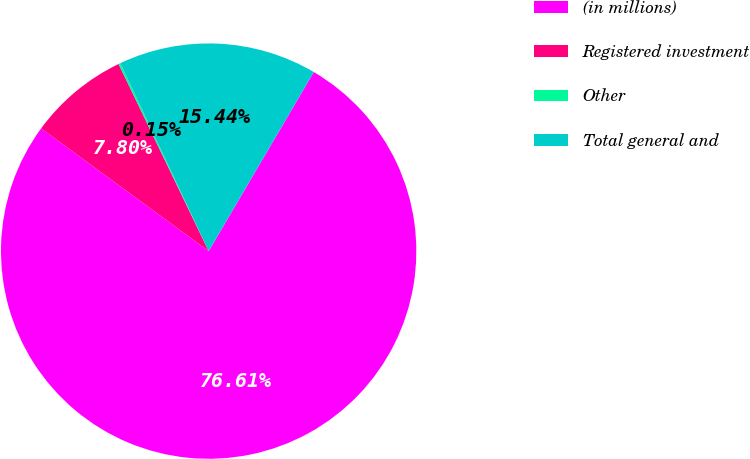<chart> <loc_0><loc_0><loc_500><loc_500><pie_chart><fcel>(in millions)<fcel>Registered investment<fcel>Other<fcel>Total general and<nl><fcel>76.61%<fcel>7.8%<fcel>0.15%<fcel>15.44%<nl></chart> 